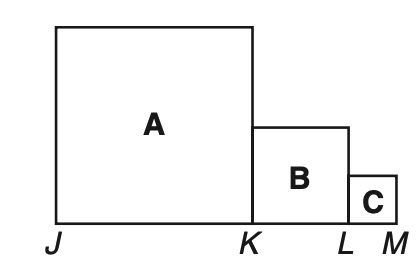Can you explain how the ratio of the sides of squares A, B, and C relate to each other? Certainly! In the image, because J K = 2K L and K L = 2L M, we know that the side length of square A is twice as long as the side length of square B, and the side length of square B is twice as long as that of square C. This puts their side lengths in a ratio of 4:2:1, which means for every unit of length square C's side has, square B's side will have two units, and square A's side will have four units, forming a geometric progression. 